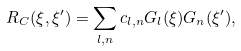Convert formula to latex. <formula><loc_0><loc_0><loc_500><loc_500>R _ { C } ( \xi , \xi ^ { \prime } ) = \sum _ { l , n } c _ { l , n } G _ { l } ( \xi ) G _ { n } ( \xi ^ { \prime } ) ,</formula> 